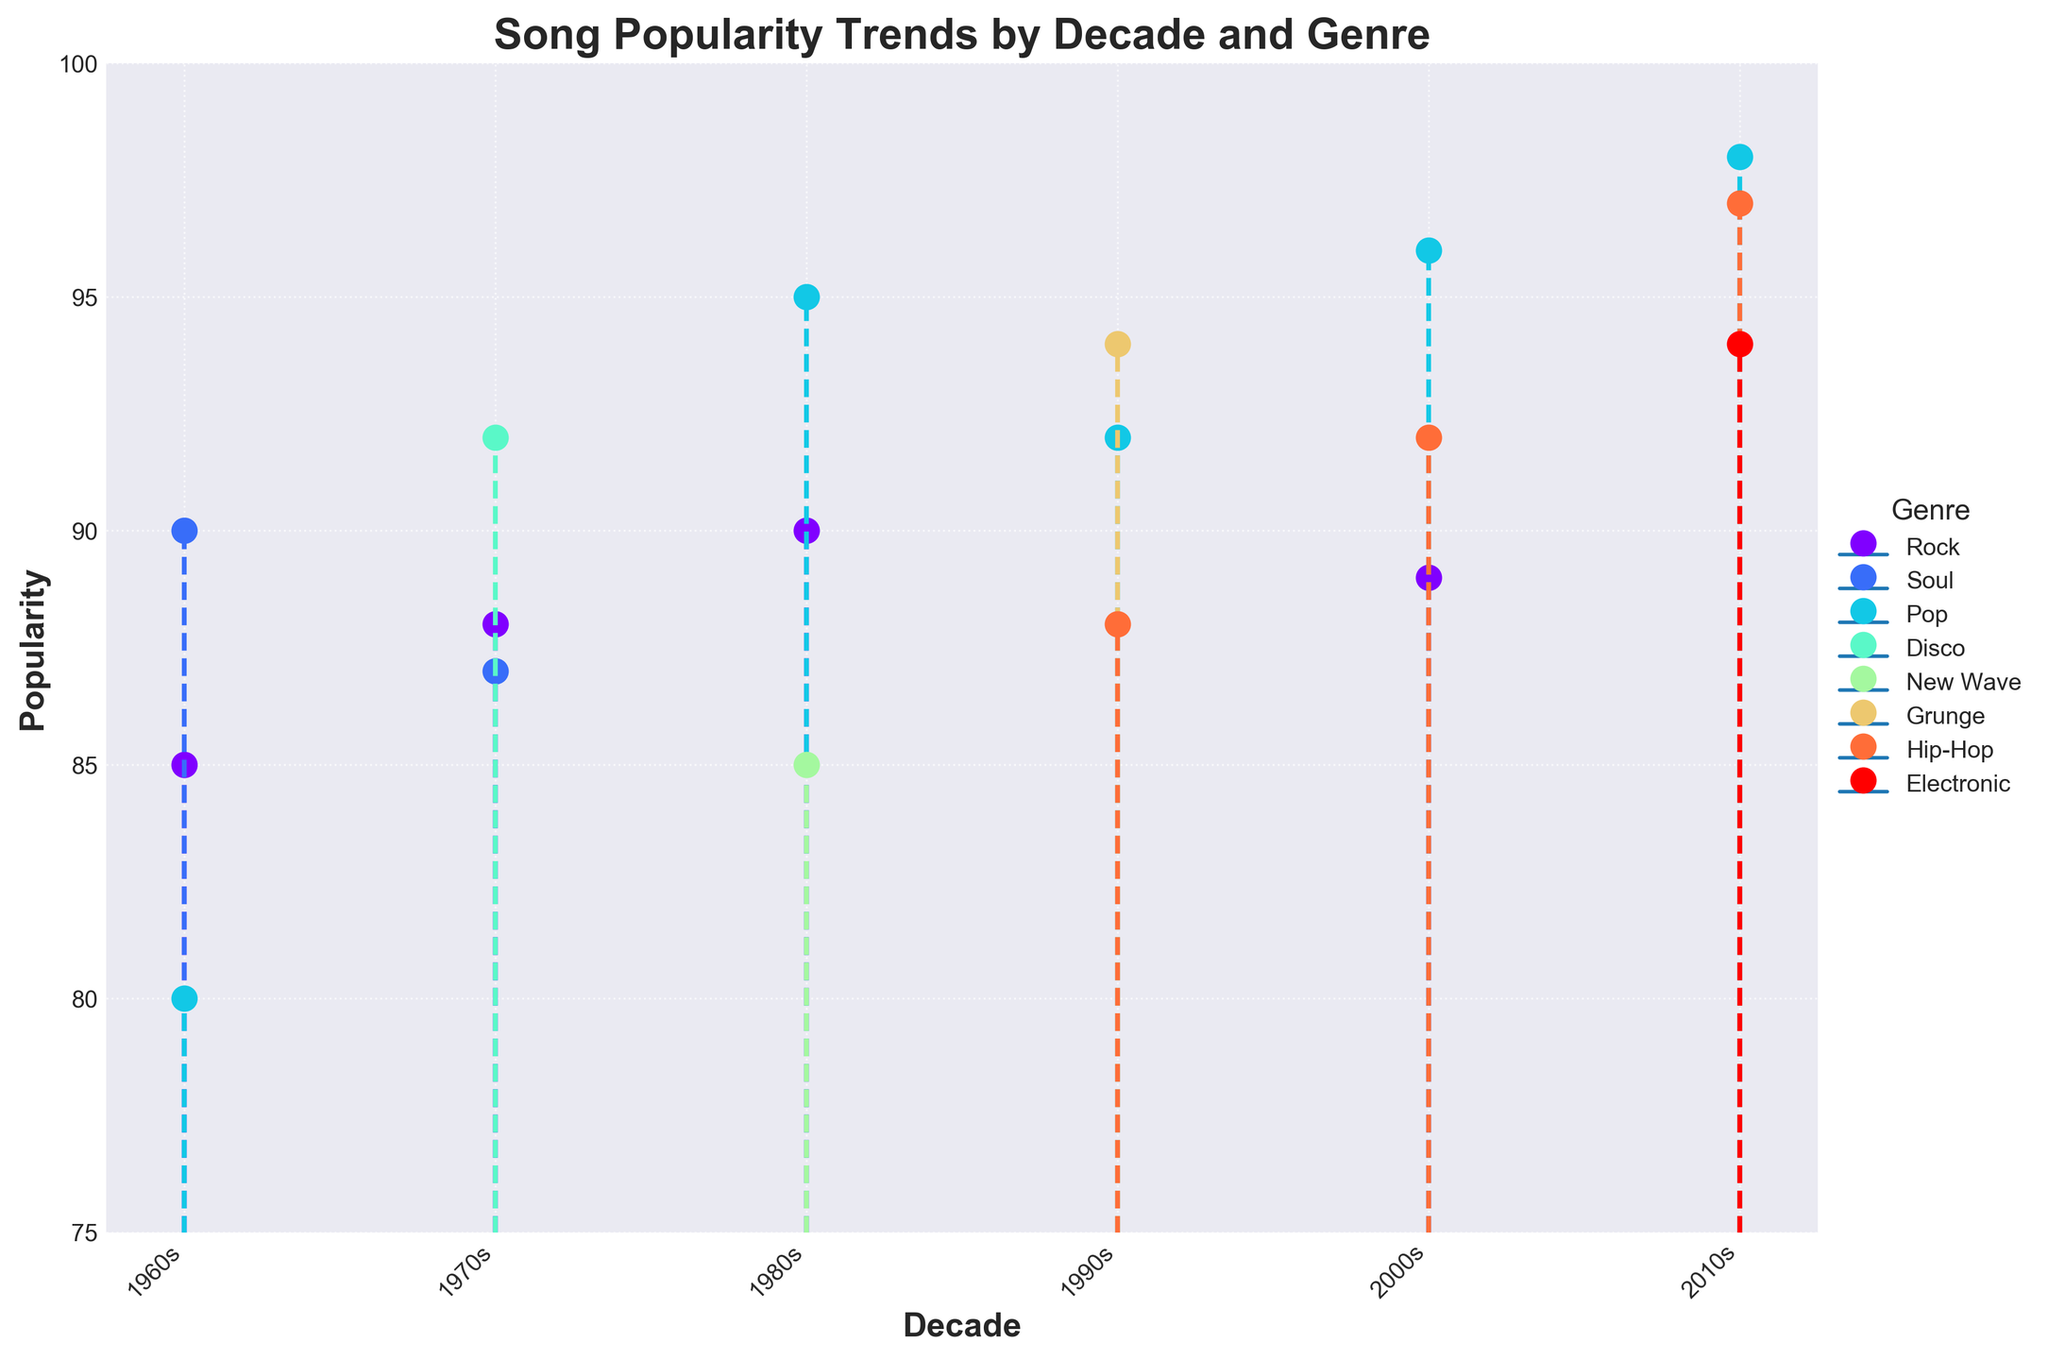What is the title of the figure? The title is displayed at the top of the figure in bold text. It describes the main theme of the visualization.
Answer: Song Popularity Trends by Decade and Genre Which genre has the highest popularity in the 2000s? To find the genre with the highest popularity in the 2000s, look at the data points corresponding to that decade and identify the one with the highest y-value (popularity).
Answer: Pop (Beyoncé, "Single Ladies (Put a Ring on It)") How many decades are represented in the figure? The x-axis lists the decades represented in the figure, each marked with a distinct tick. Count the ticks to find the number of decades.
Answer: 5 What decade had the highest overall popularity across all genres? To determine this, compare the highest popularity values across all genres for each decade and identify the decade with the highest value.
Answer: 2010s Compare the popularity of Michael Jackson's "Billie Jean" in the 1980s to Beyoncé's "Single Ladies" in the 2000s. Which one is higher and by how much? Locate the popularity values for both songs and subtract the popularity of "Billie Jean" from "Single Ladies". Michael Jackson's "Billie Jean" has a popularity of 95, while Beyoncé's "Single Ladies" has 96.
Answer: "Single Ladies" is higher by 1 Which genre has the most data points represented across all decades? Count the data points for each genre across all decades and compare. The genre with the most data points is the answer.
Answer: Pop Which song had the lowest popularity in the 1960s, and what was its value? Look at the data points corresponding to the 1960s and identify the one with the lowest popularity.
Answer: The Beach Boys' "Good Vibrations" with a popularity of 80 What is the range of popularity values for the 1990s? Find the minimum and maximum popularity values for songs in the 1990s and subtract the minimum from the maximum. The minimum is Tupac's 88 and the maximum is Nirvana's 94.
Answer: 6 How does the popularity of disco in the 1970s compare to that of electronic music in the 2010s? Locate and compare the popularity values for disco in the 1970s (ABBA's "Dancing Queen" with 92) and electronic music in the 2010s (Calvin Harris' "Feel So Close" with 94).
Answer: Electronic is higher by 2 What is the average popularity of songs in the 1980s? Add the popularity values for all songs in the 1980s and divide by the number of songs. The values are 95, 90, and 85. Sum = 270. Number of songs = 3. Average = 270/3.
Answer: 90 